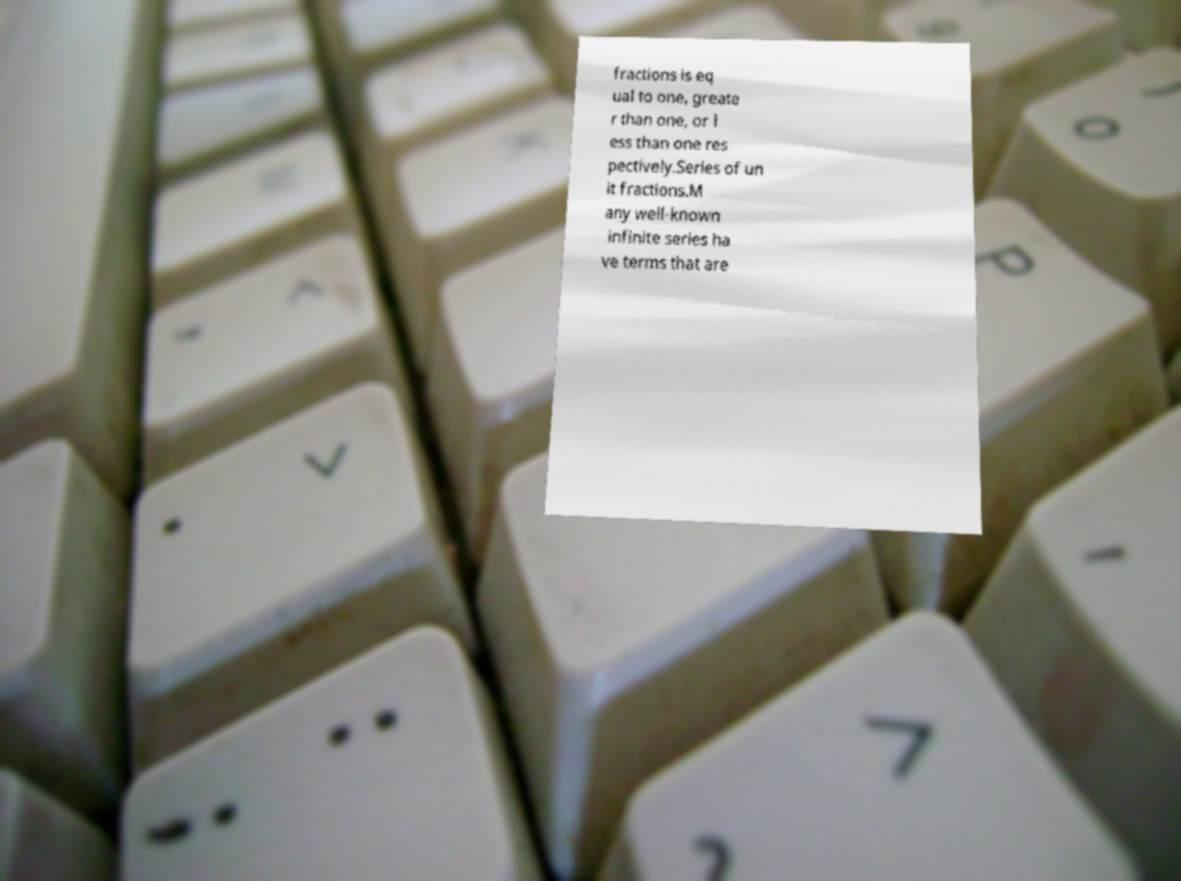Please read and relay the text visible in this image. What does it say? fractions is eq ual to one, greate r than one, or l ess than one res pectively.Series of un it fractions.M any well-known infinite series ha ve terms that are 